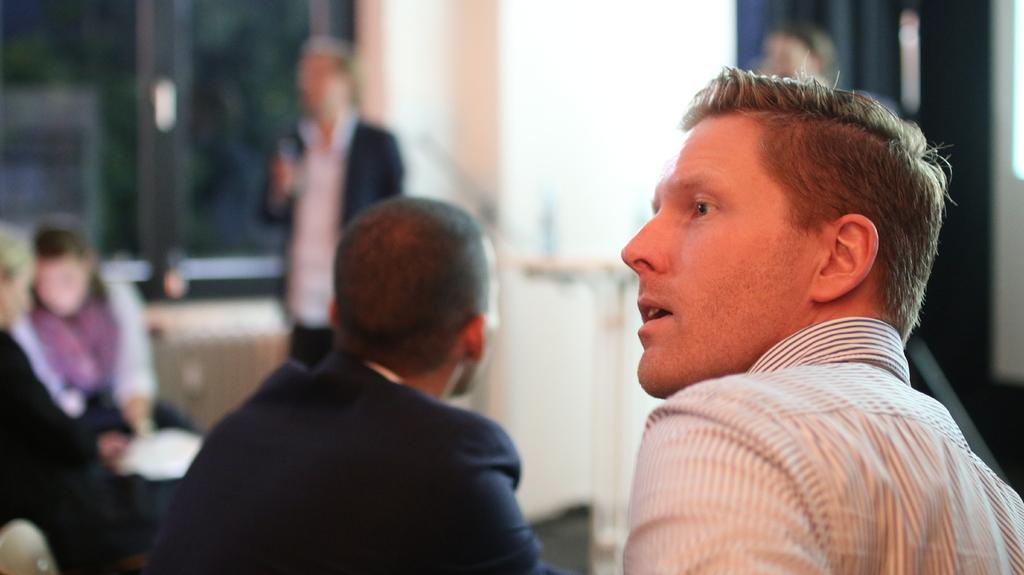What is the main subject of the image? There is a person in the image. Can you describe any other people visible in the image? Yes, there are other people visible in the image. What type of writer is the person holding a hammer in the image? There is no person holding a hammer in the image, nor is there any reference to a writer. 